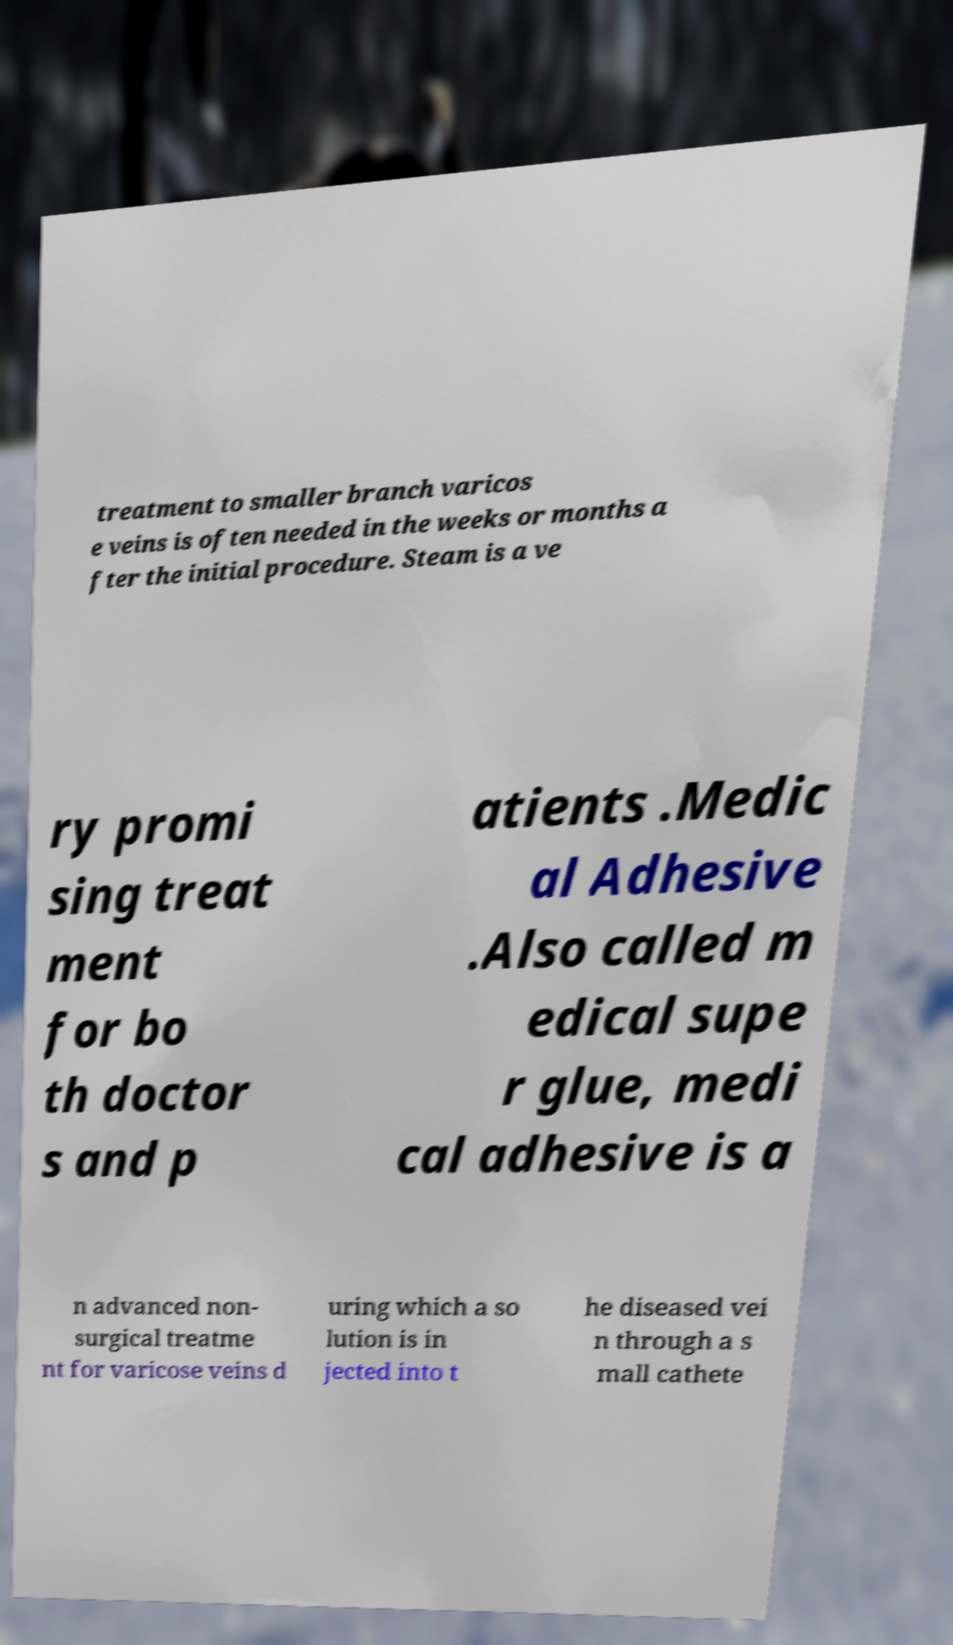I need the written content from this picture converted into text. Can you do that? treatment to smaller branch varicos e veins is often needed in the weeks or months a fter the initial procedure. Steam is a ve ry promi sing treat ment for bo th doctor s and p atients .Medic al Adhesive .Also called m edical supe r glue, medi cal adhesive is a n advanced non- surgical treatme nt for varicose veins d uring which a so lution is in jected into t he diseased vei n through a s mall cathete 